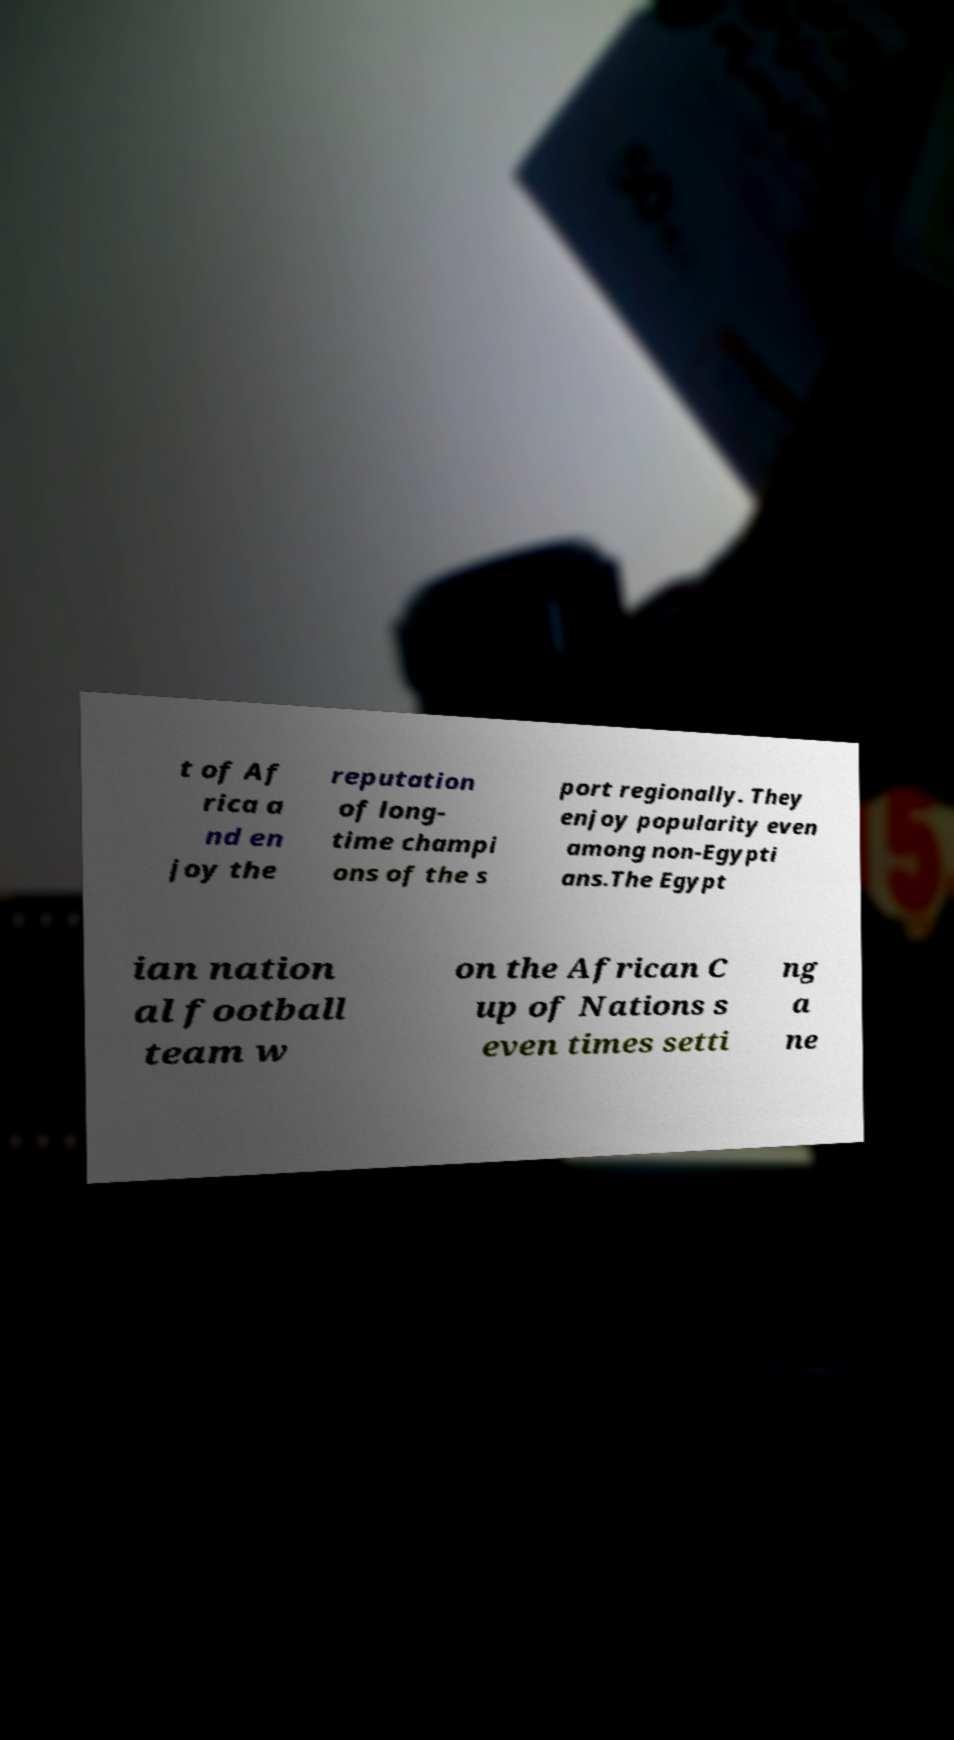Can you accurately transcribe the text from the provided image for me? t of Af rica a nd en joy the reputation of long- time champi ons of the s port regionally. They enjoy popularity even among non-Egypti ans.The Egypt ian nation al football team w on the African C up of Nations s even times setti ng a ne 